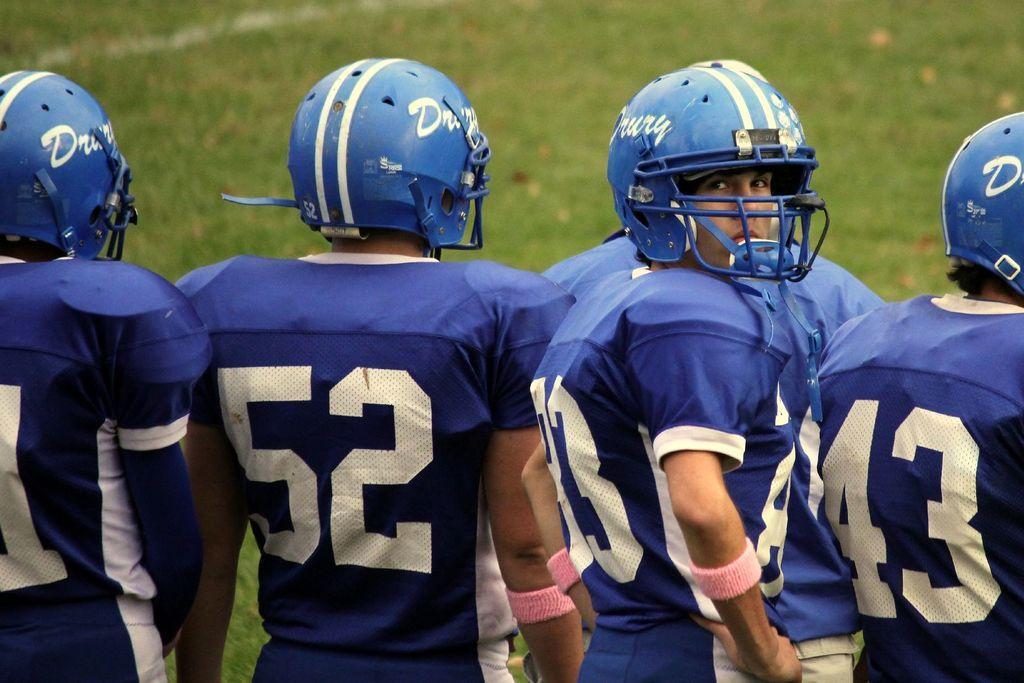In one or two sentences, can you explain what this image depicts? In this image there are few persons wearing blue color sports dress. They are wearing helmets. They are standing and facing at the opposite direction. A person is facing at the front side of the image. Background there is grassland. 